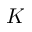<formula> <loc_0><loc_0><loc_500><loc_500>K</formula> 